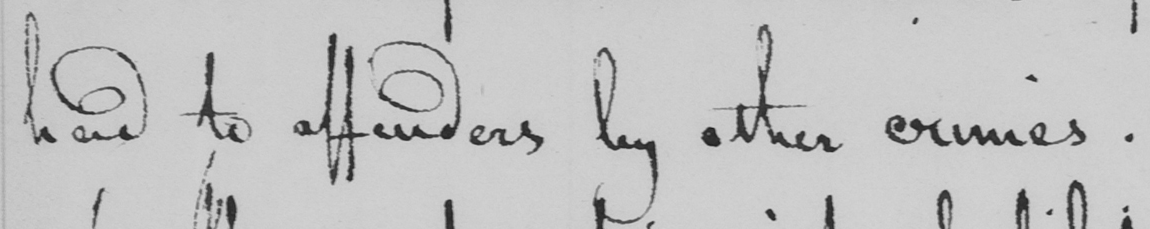What is written in this line of handwriting? had to affenders by other crimes . 